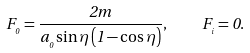<formula> <loc_0><loc_0><loc_500><loc_500>F _ { _ { 0 } } = \frac { 2 m } { a _ { _ { 0 } } \sin \eta \left ( 1 - \cos \eta \right ) } , \quad F _ { _ { i } } = 0 .</formula> 